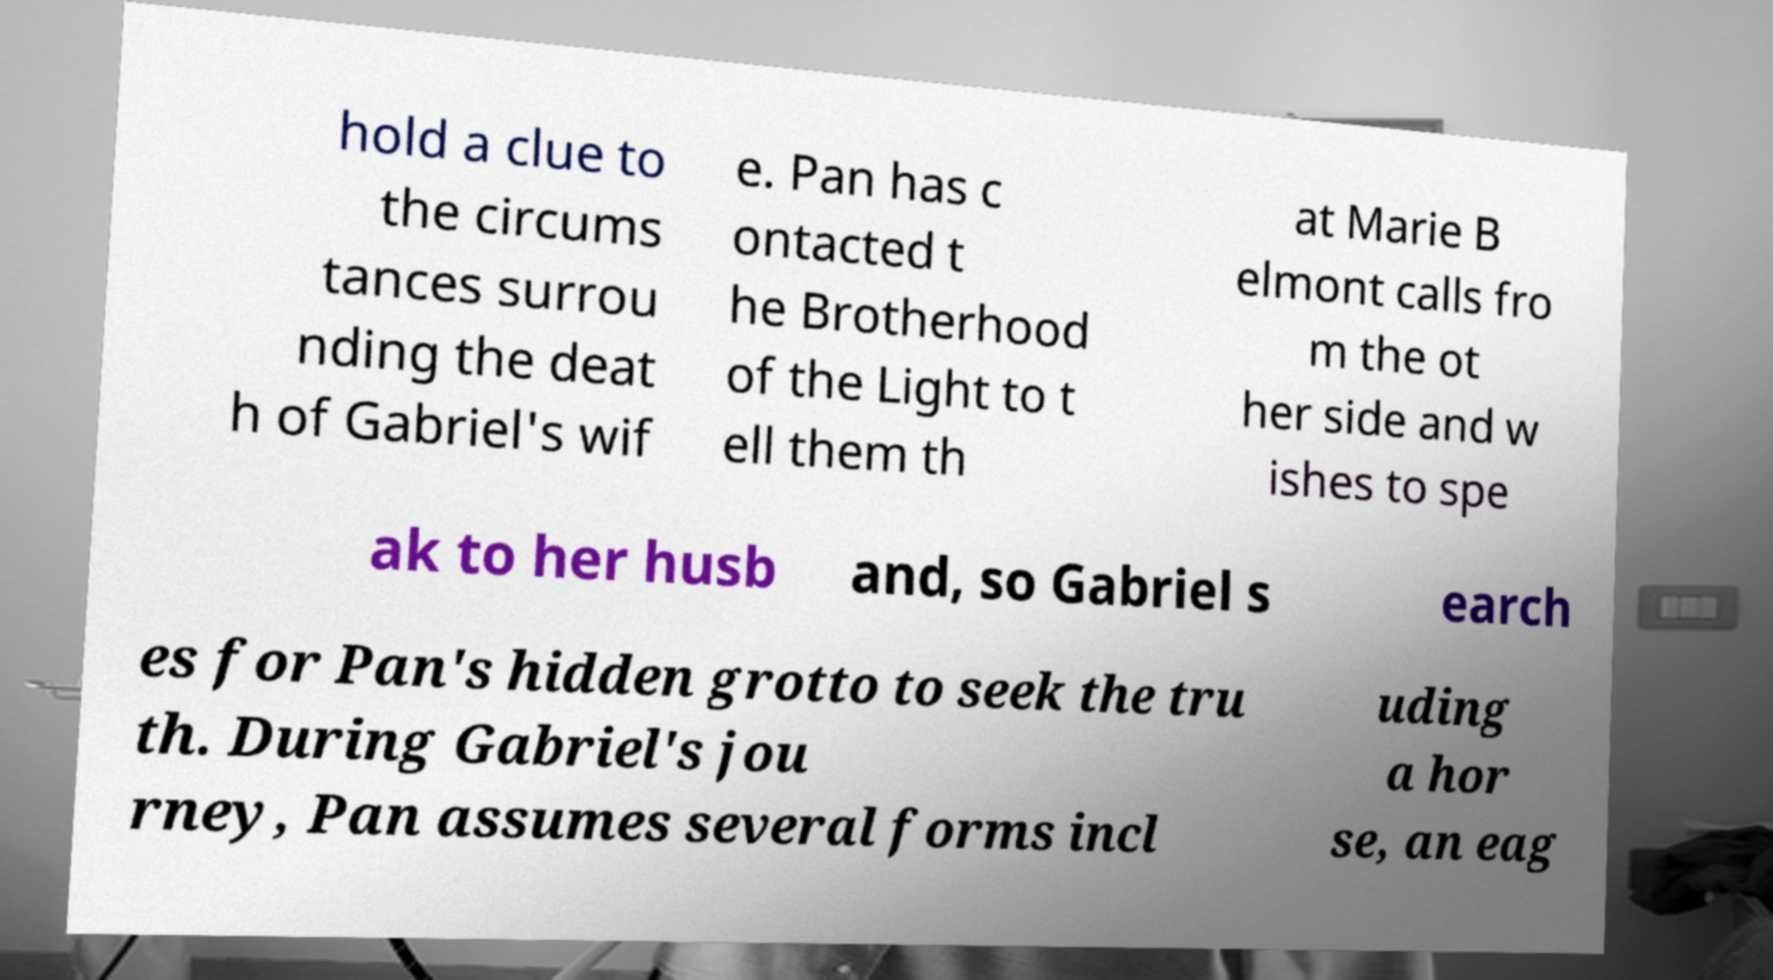Can you read and provide the text displayed in the image?This photo seems to have some interesting text. Can you extract and type it out for me? hold a clue to the circums tances surrou nding the deat h of Gabriel's wif e. Pan has c ontacted t he Brotherhood of the Light to t ell them th at Marie B elmont calls fro m the ot her side and w ishes to spe ak to her husb and, so Gabriel s earch es for Pan's hidden grotto to seek the tru th. During Gabriel's jou rney, Pan assumes several forms incl uding a hor se, an eag 